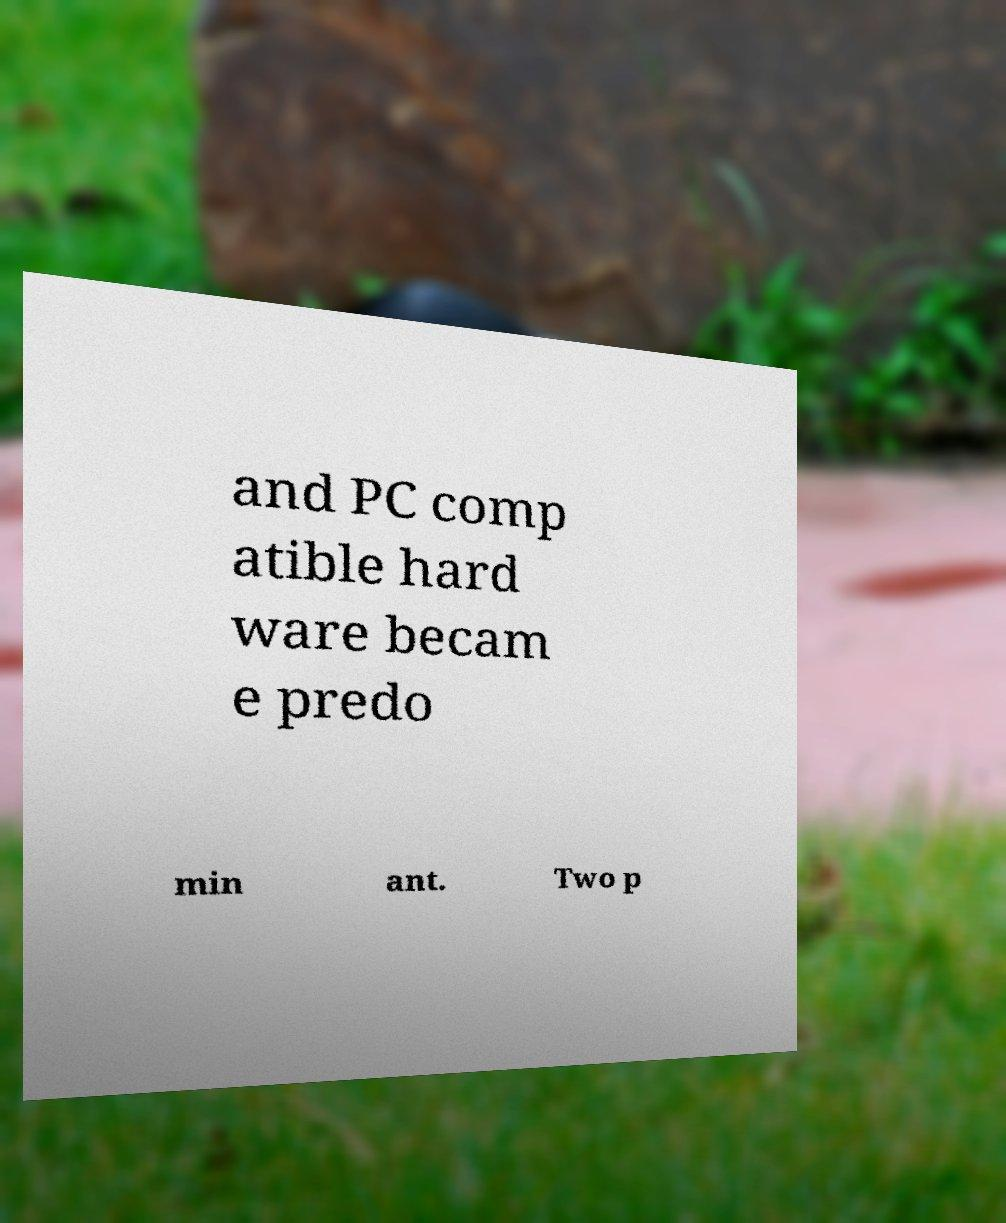Can you read and provide the text displayed in the image?This photo seems to have some interesting text. Can you extract and type it out for me? and PC comp atible hard ware becam e predo min ant. Two p 